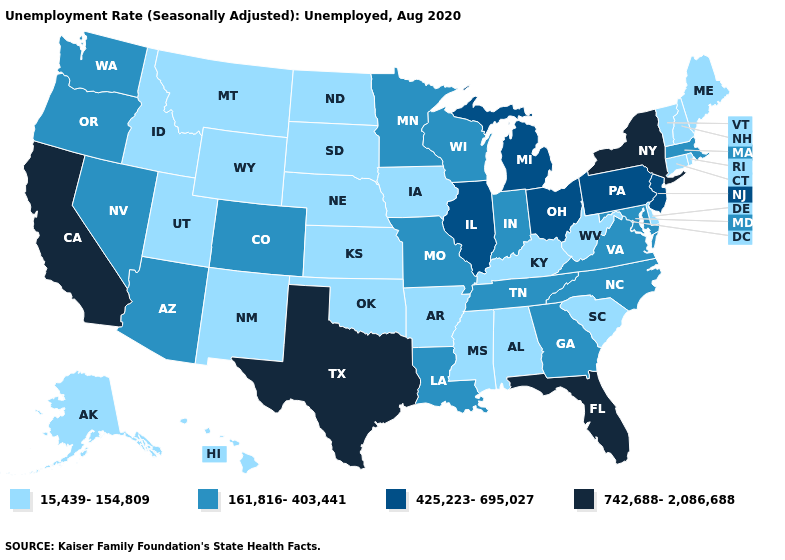What is the value of Oklahoma?
Answer briefly. 15,439-154,809. Does Texas have the highest value in the South?
Quick response, please. Yes. Which states have the lowest value in the USA?
Give a very brief answer. Alabama, Alaska, Arkansas, Connecticut, Delaware, Hawaii, Idaho, Iowa, Kansas, Kentucky, Maine, Mississippi, Montana, Nebraska, New Hampshire, New Mexico, North Dakota, Oklahoma, Rhode Island, South Carolina, South Dakota, Utah, Vermont, West Virginia, Wyoming. What is the value of New Jersey?
Give a very brief answer. 425,223-695,027. Name the states that have a value in the range 425,223-695,027?
Write a very short answer. Illinois, Michigan, New Jersey, Ohio, Pennsylvania. What is the lowest value in states that border Ohio?
Concise answer only. 15,439-154,809. What is the value of Virginia?
Short answer required. 161,816-403,441. Does Pennsylvania have a higher value than Massachusetts?
Quick response, please. Yes. Name the states that have a value in the range 15,439-154,809?
Answer briefly. Alabama, Alaska, Arkansas, Connecticut, Delaware, Hawaii, Idaho, Iowa, Kansas, Kentucky, Maine, Mississippi, Montana, Nebraska, New Hampshire, New Mexico, North Dakota, Oklahoma, Rhode Island, South Carolina, South Dakota, Utah, Vermont, West Virginia, Wyoming. Which states have the highest value in the USA?
Write a very short answer. California, Florida, New York, Texas. Does Virginia have a higher value than Ohio?
Write a very short answer. No. Name the states that have a value in the range 742,688-2,086,688?
Keep it brief. California, Florida, New York, Texas. Does West Virginia have the same value as California?
Concise answer only. No. 